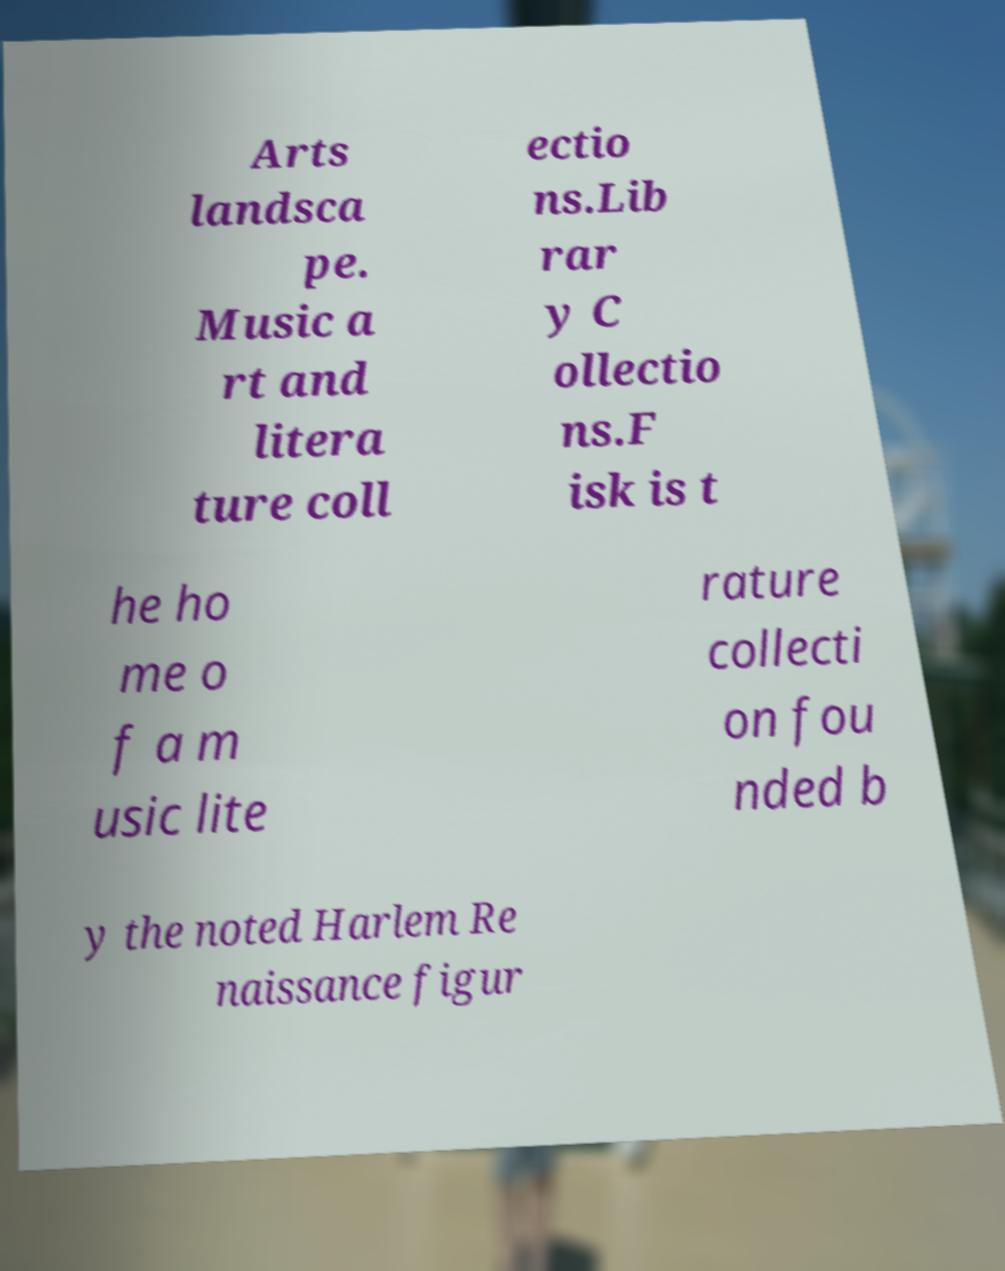Can you read and provide the text displayed in the image?This photo seems to have some interesting text. Can you extract and type it out for me? Arts landsca pe. Music a rt and litera ture coll ectio ns.Lib rar y C ollectio ns.F isk is t he ho me o f a m usic lite rature collecti on fou nded b y the noted Harlem Re naissance figur 